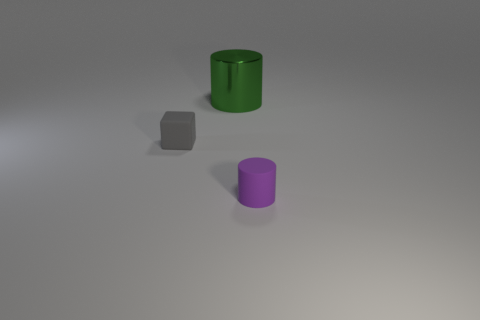There is a cylinder left of the tiny rubber object that is in front of the small rubber cube; are there any large things that are in front of it?
Make the answer very short. No. What shape is the object that is the same size as the rubber block?
Your answer should be very brief. Cylinder. What number of other things are there of the same color as the shiny object?
Your answer should be compact. 0. What is the cube made of?
Offer a very short reply. Rubber. How many other objects are the same material as the tiny purple cylinder?
Ensure brevity in your answer.  1. There is a thing that is behind the rubber cylinder and on the right side of the gray object; what is its size?
Your answer should be compact. Large. There is a rubber thing that is left of the rubber thing right of the metal cylinder; what shape is it?
Ensure brevity in your answer.  Cube. Are there any other things that are the same shape as the gray matte thing?
Give a very brief answer. No. Are there an equal number of big green objects that are left of the big metallic cylinder and purple objects?
Ensure brevity in your answer.  No. There is a big metal thing; does it have the same color as the rubber thing that is to the left of the tiny purple matte cylinder?
Offer a very short reply. No. 